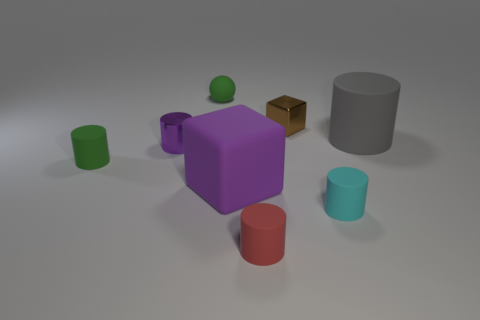There is a tiny rubber cylinder to the left of the red object; is there a small red cylinder in front of it?
Offer a terse response. Yes. There is a cube that is behind the tiny purple object; what is it made of?
Offer a very short reply. Metal. Does the large thing right of the small brown metallic thing have the same material as the block that is on the left side of the metal block?
Provide a succinct answer. Yes. Are there an equal number of small cyan rubber objects behind the green matte cylinder and gray cylinders that are in front of the cyan object?
Your response must be concise. Yes. How many big green cylinders have the same material as the ball?
Offer a terse response. 0. What shape is the rubber thing that is the same color as the sphere?
Ensure brevity in your answer.  Cylinder. There is a rubber object that is in front of the tiny cyan cylinder in front of the tiny brown metal thing; what size is it?
Keep it short and to the point. Small. There is a green object behind the big gray matte object; is its shape the same as the purple thing that is behind the green cylinder?
Offer a terse response. No. Are there an equal number of small matte cylinders in front of the rubber sphere and small matte cylinders?
Your response must be concise. Yes. What is the color of the big thing that is the same shape as the small purple metal thing?
Provide a short and direct response. Gray. 